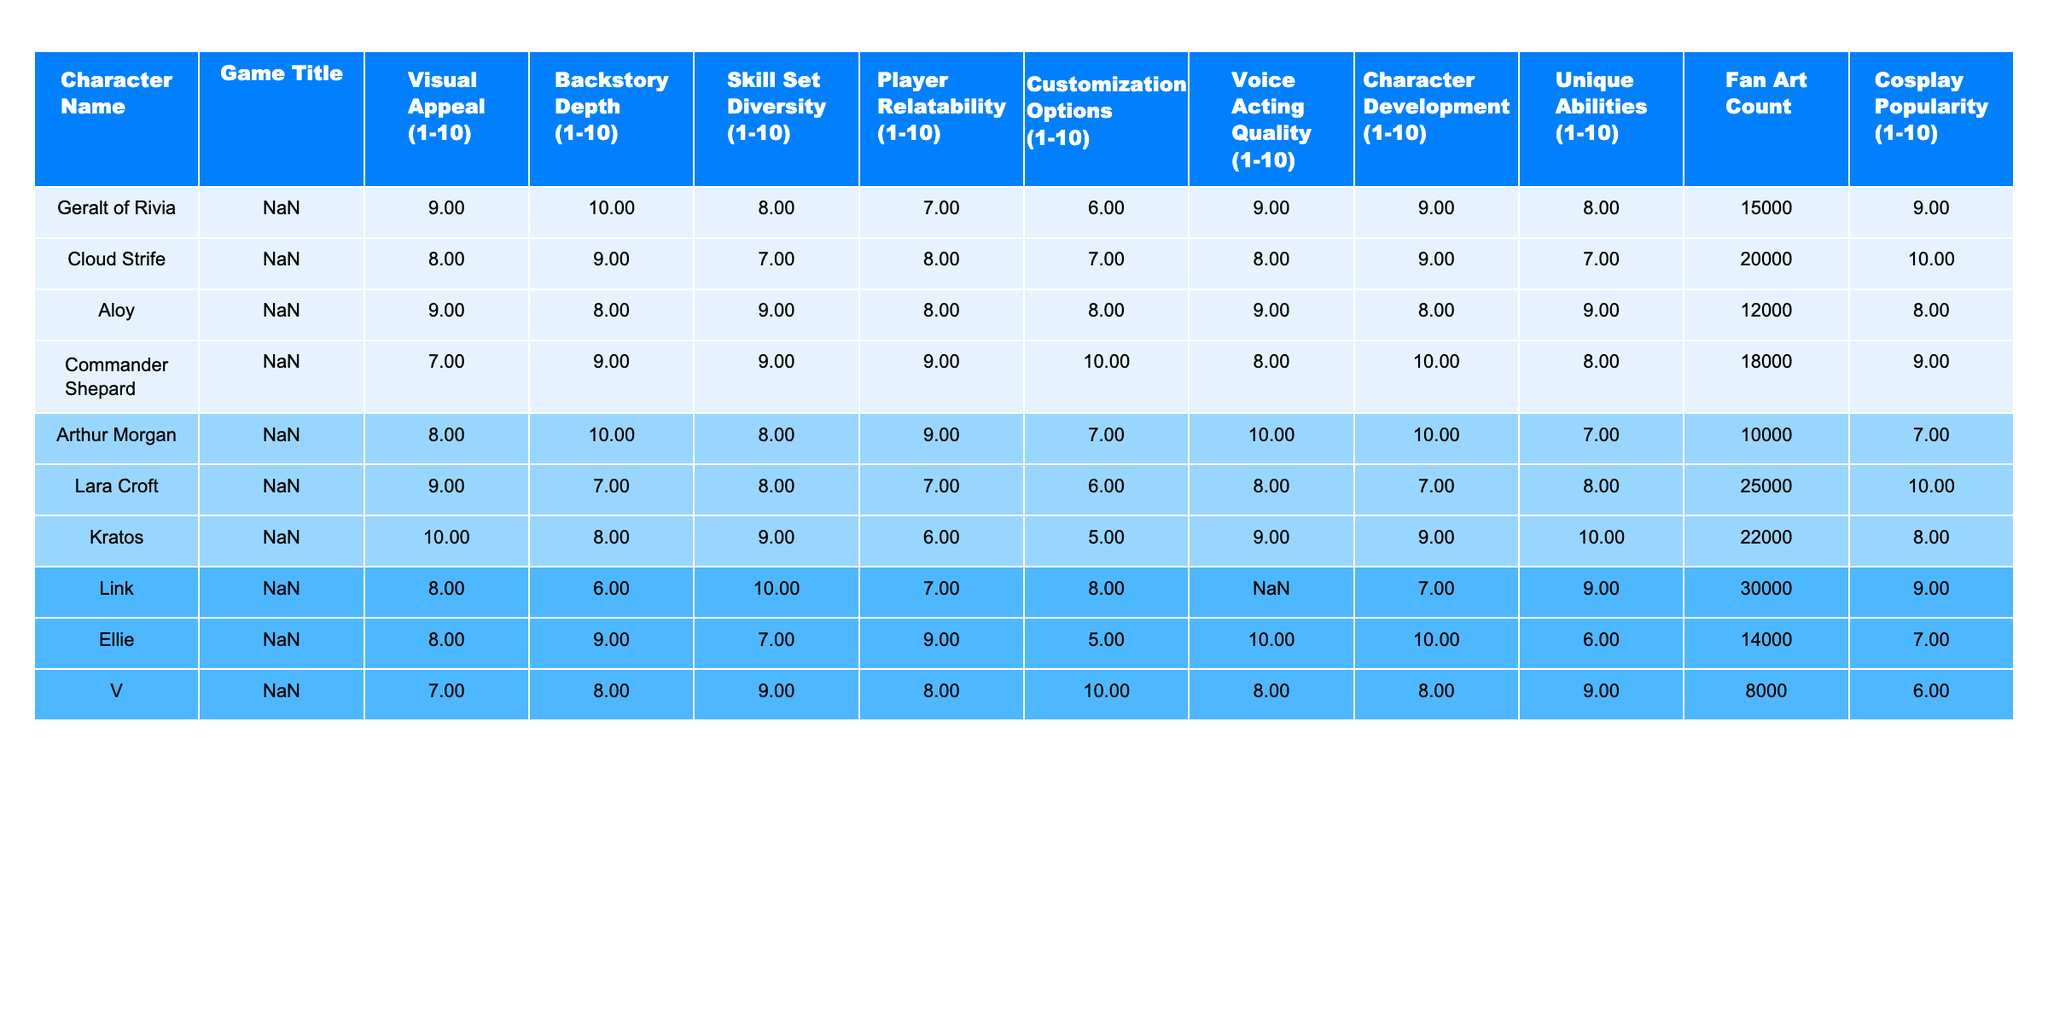What is the highest visual appeal rating among these characters? By examining the "Visual Appeal" column, the character with the highest rating is Kratos from God of War (2018), who received a score of 10.
Answer: 10 Which character has the most fan art? Looking at the "Fan Art Count" column, Cloud Strife has the highest fan art count with 20,000 pieces.
Answer: 20,000 Is there a character that has both a customization options rating of 10 and character development rating of 10? Checking both the "Customization Options" and "Character Development" columns, Commander Shepard has a rating of 10 in customization options and 10 in character development.
Answer: Yes What is the average backstory depth rating of all characters? To find the average, sum all values in the "Backstory Depth" column (10 + 9 + 8 + 9 + 10 + 7 + 8 + 6 + 9 + 8 = 82) and divide by 10, which gives an average of 8.2.
Answer: 8.2 Which character has the lowest voice acting quality rating, and what is that rating? The character with the lowest rating in "Voice Acting Quality" is V from Cyberpunk 2077, who received a score of 6.
Answer: 6 How does Link's skill set diversity rating compare to Eleanor's? Link's skill set diversity rating is 10, while Ellie’s is 7, indicating that Link's rating is higher by 3 points.
Answer: Higher by 3 points Which character has the highest cosplay popularity rating? By examining the "Cosplay Popularity" column, Cloud Strife has the highest cosplay popularity rating of 10.
Answer: 10 What is the total count of fan art for characters with customization ratings of 10? The characters with a customization rating of 10 are Commander Shepard and V, summing their fan art counts (18,000 + 8,000 = 26,000).
Answer: 26,000 How many characters have a player relatability rating of 9 or higher? Checking the "Player Relatability" column, there are four characters (Cloud Strife, Commander Shepard, Arthur Morgan, and Ellie) that meet the criteria, equating to a total of 4 characters.
Answer: 4 Is there a character with a skill set diversity rating of 10 but a customization options rating below 6? Reviewing the "Skill Set Diversity" and "Customization Options" columns, there are no characters that have a skill set diversity rating of 10 and a customization options rating below 6.
Answer: No 